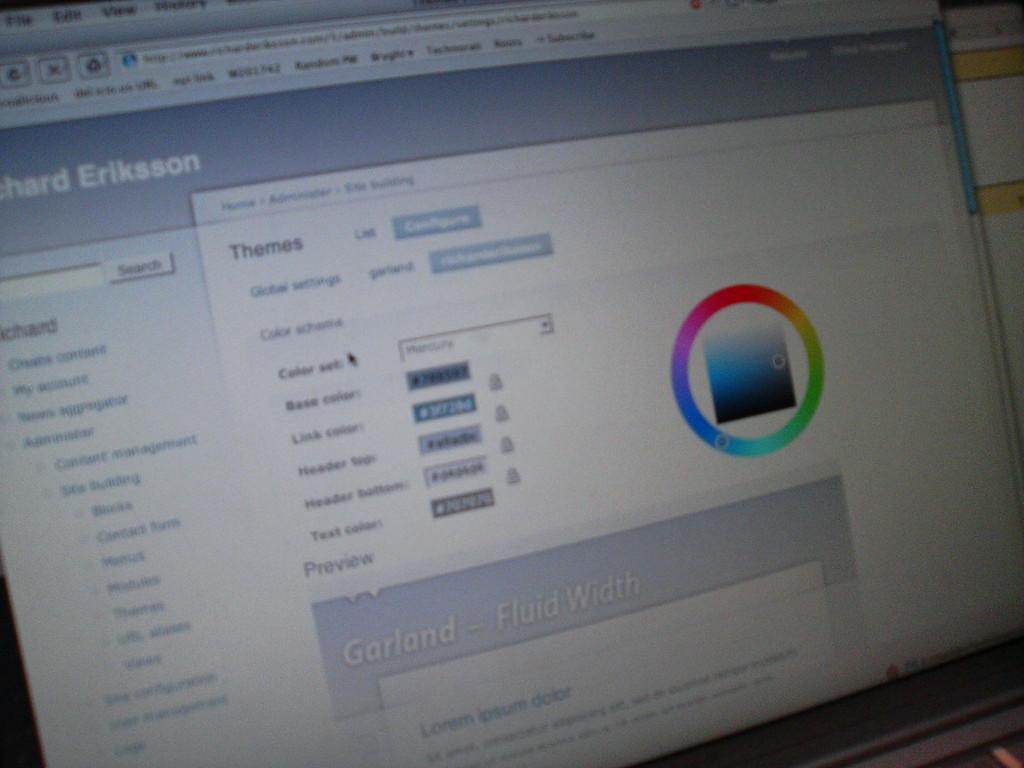<image>
Describe the image concisely. a computer screen is open to a page with word Eriksson on the top left 